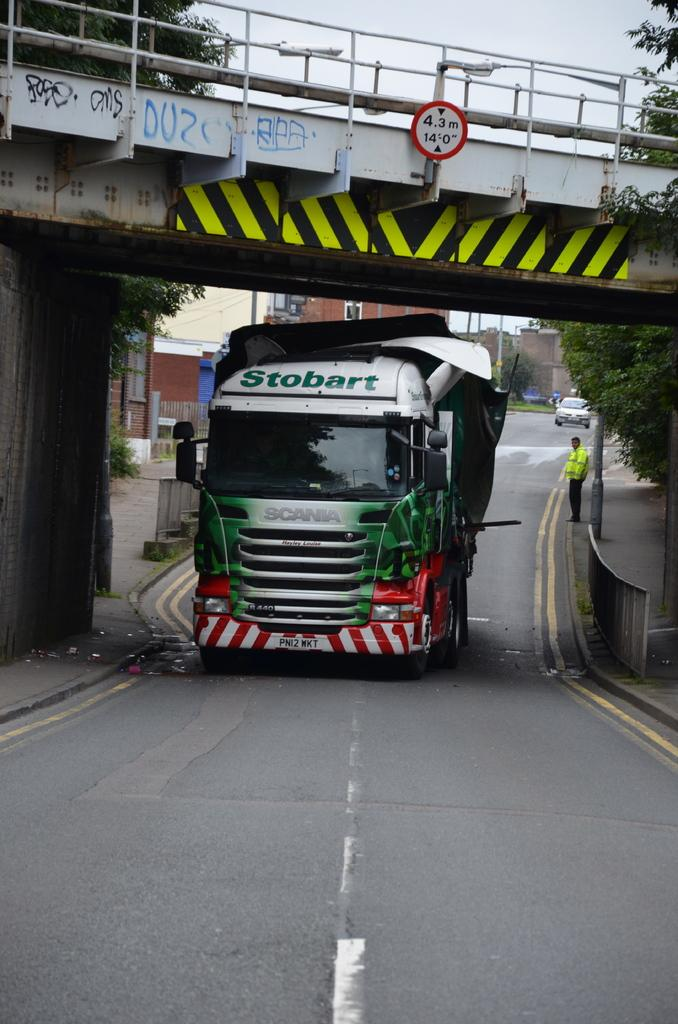What can be seen on the road in the image? There are vehicles on the road in the image. What type of structures can be seen in the image? There are fences, a bridge, and buildings in the image. Can you describe the natural elements in the image? There are trees and the sky visible in the image. What is the person in the image doing? There is a person standing on the footpath in the image. Are there any objects present in the image? Yes, there are some objects in the image. Is the person in the image swimming in the river? There is no river present in the image, and the person is standing on the footpath. What type of flag is being waved by the person in the image? There is no flag present in the image. 